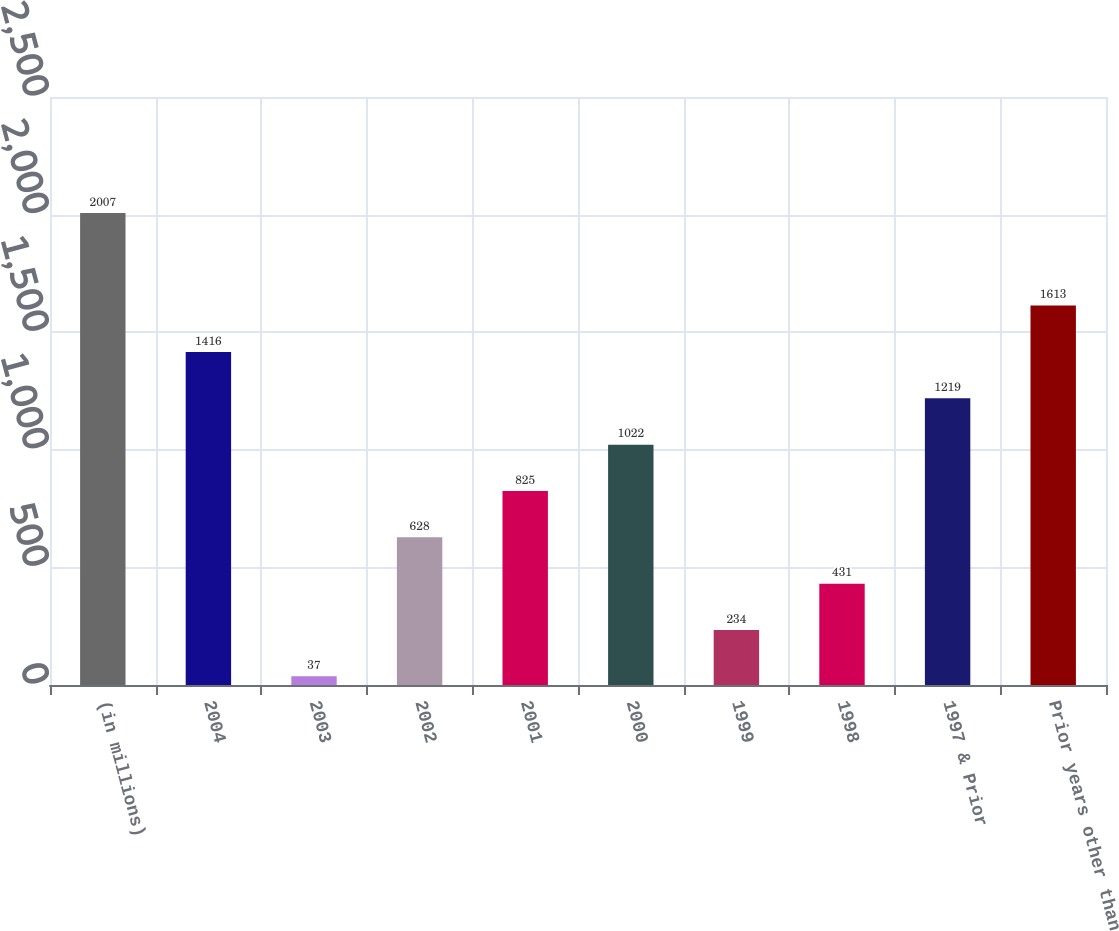Convert chart. <chart><loc_0><loc_0><loc_500><loc_500><bar_chart><fcel>(in millions)<fcel>2004<fcel>2003<fcel>2002<fcel>2001<fcel>2000<fcel>1999<fcel>1998<fcel>1997 & Prior<fcel>Prior years other than<nl><fcel>2007<fcel>1416<fcel>37<fcel>628<fcel>825<fcel>1022<fcel>234<fcel>431<fcel>1219<fcel>1613<nl></chart> 